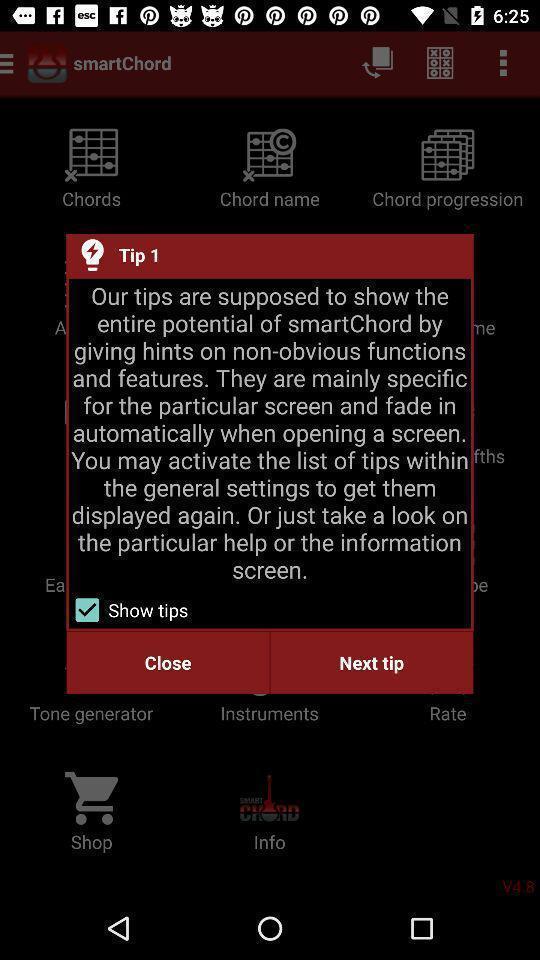Provide a detailed account of this screenshot. Popup for tips in the musical instrument learning app. 